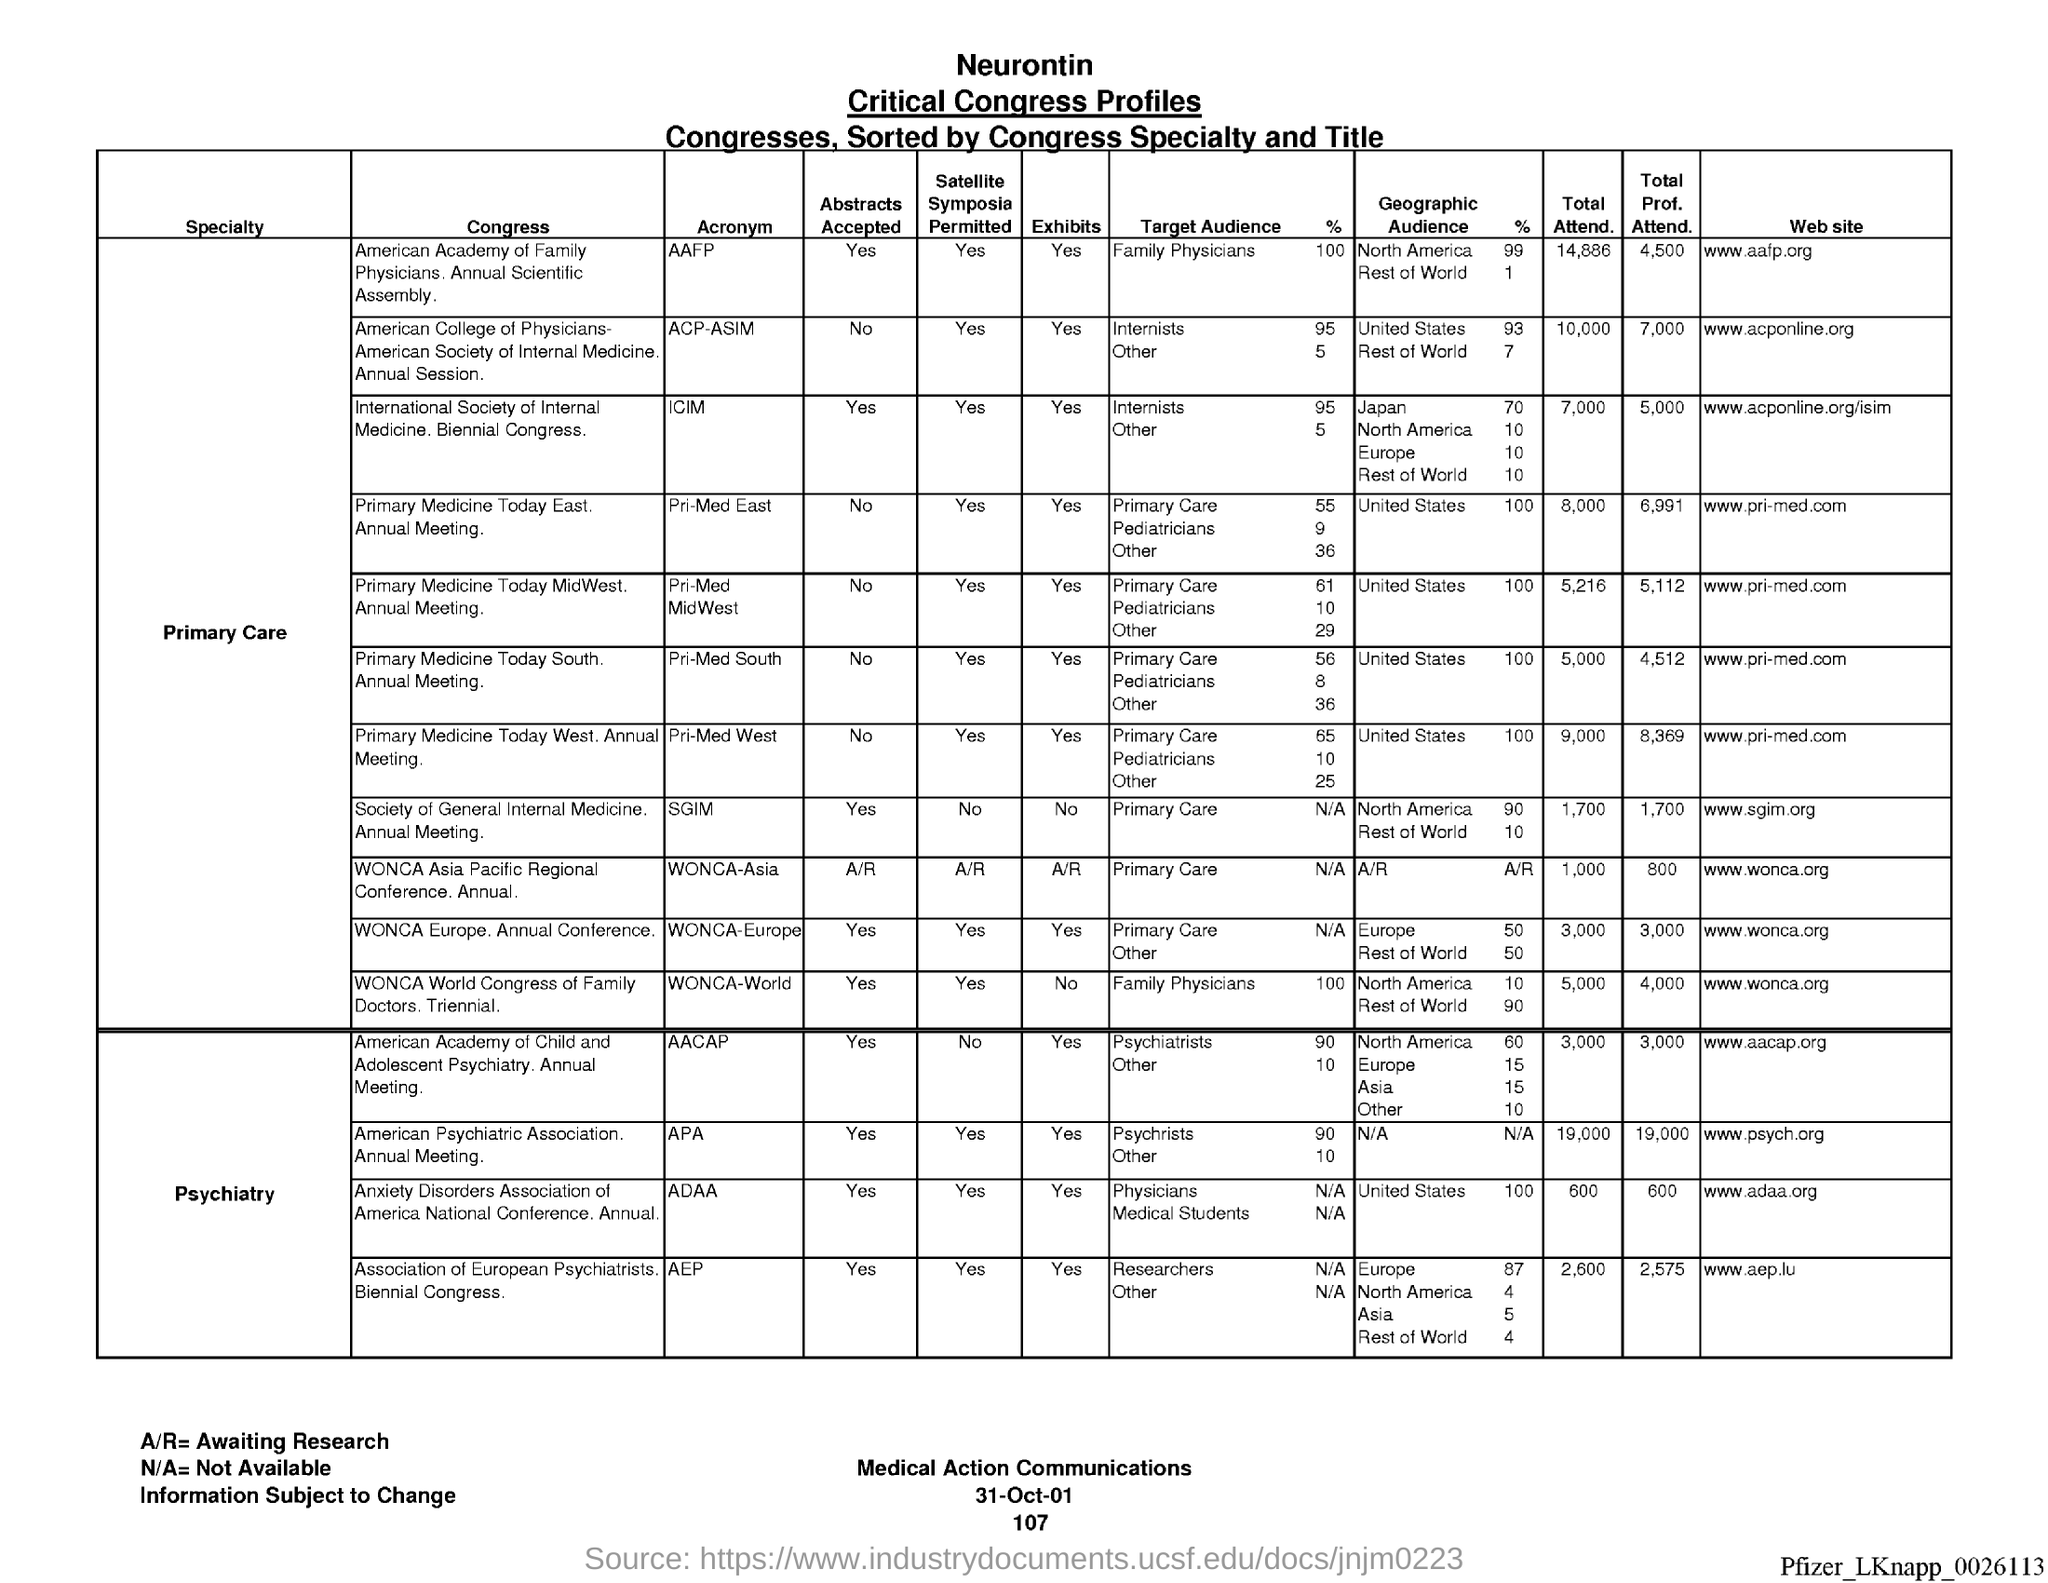Mention a couple of crucial points in this snapshot. The total attendance for the ICIM event was 7,000. The total attendance for Pri-med East was 8,000. The total attendance for the ACP-ASIV event was 10,000. The total attendance for the Society of Government Meeting Professionals was 1,700. The total attendance for the Annual Prayer Assembly (APA) was 19,000. 